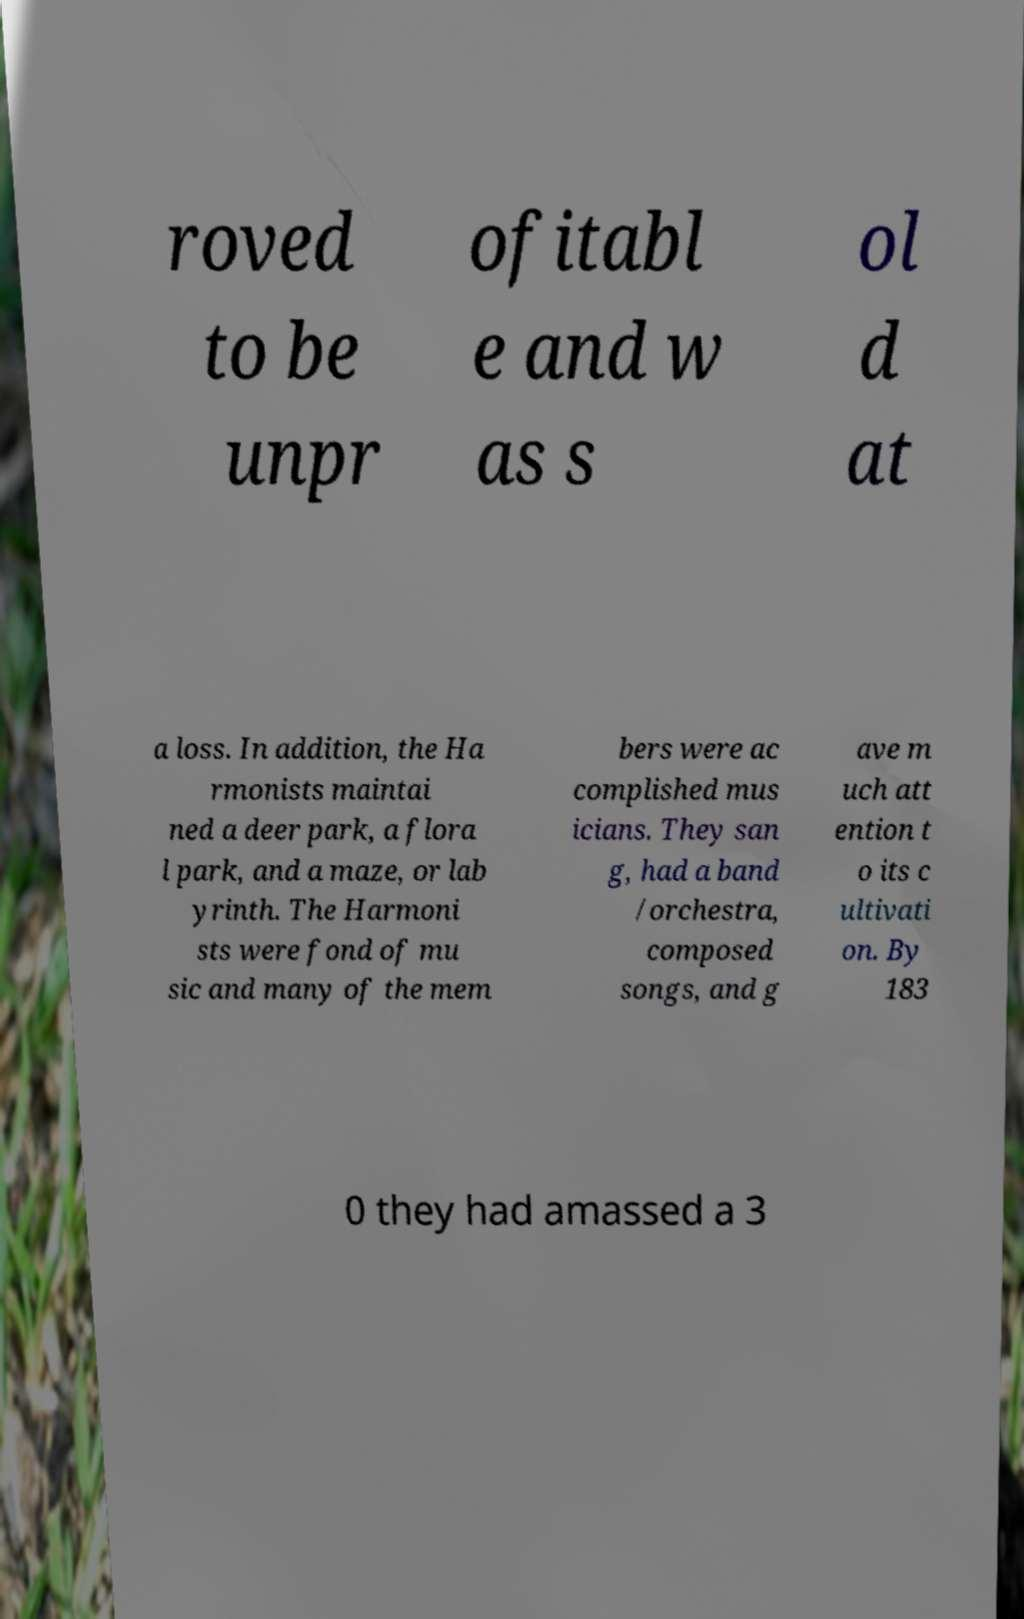Could you extract and type out the text from this image? roved to be unpr ofitabl e and w as s ol d at a loss. In addition, the Ha rmonists maintai ned a deer park, a flora l park, and a maze, or lab yrinth. The Harmoni sts were fond of mu sic and many of the mem bers were ac complished mus icians. They san g, had a band /orchestra, composed songs, and g ave m uch att ention t o its c ultivati on. By 183 0 they had amassed a 3 